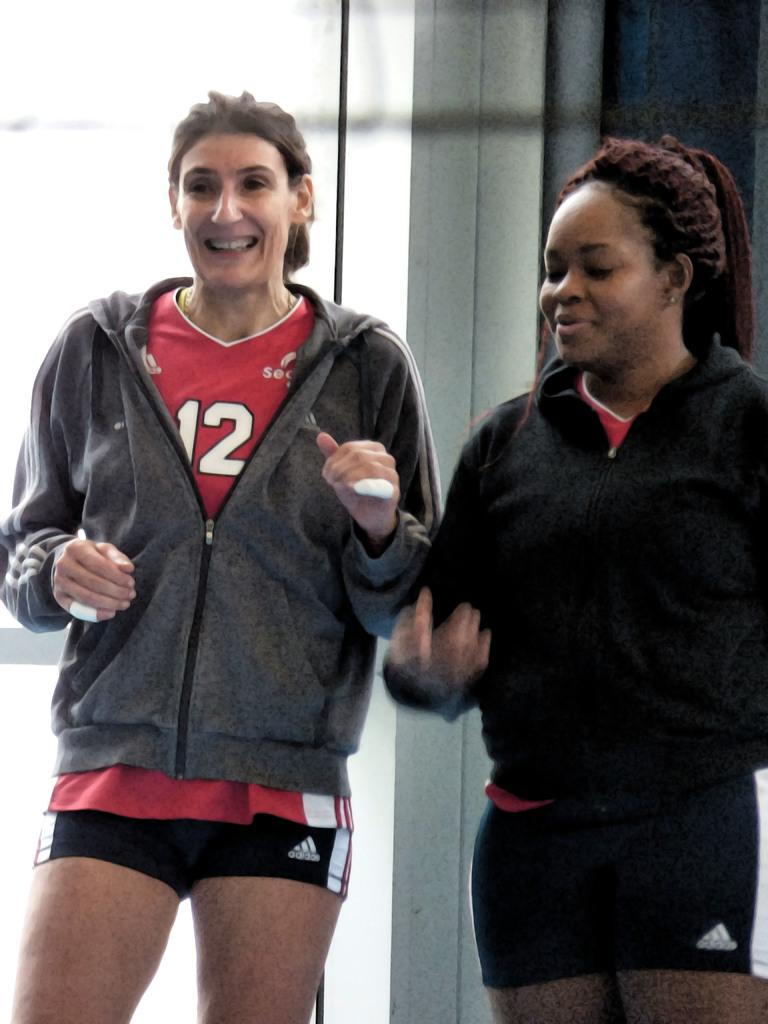<image>
Describe the image concisely. Two women weaing sports or workout clothing, one of which has a number 12 jersey. 